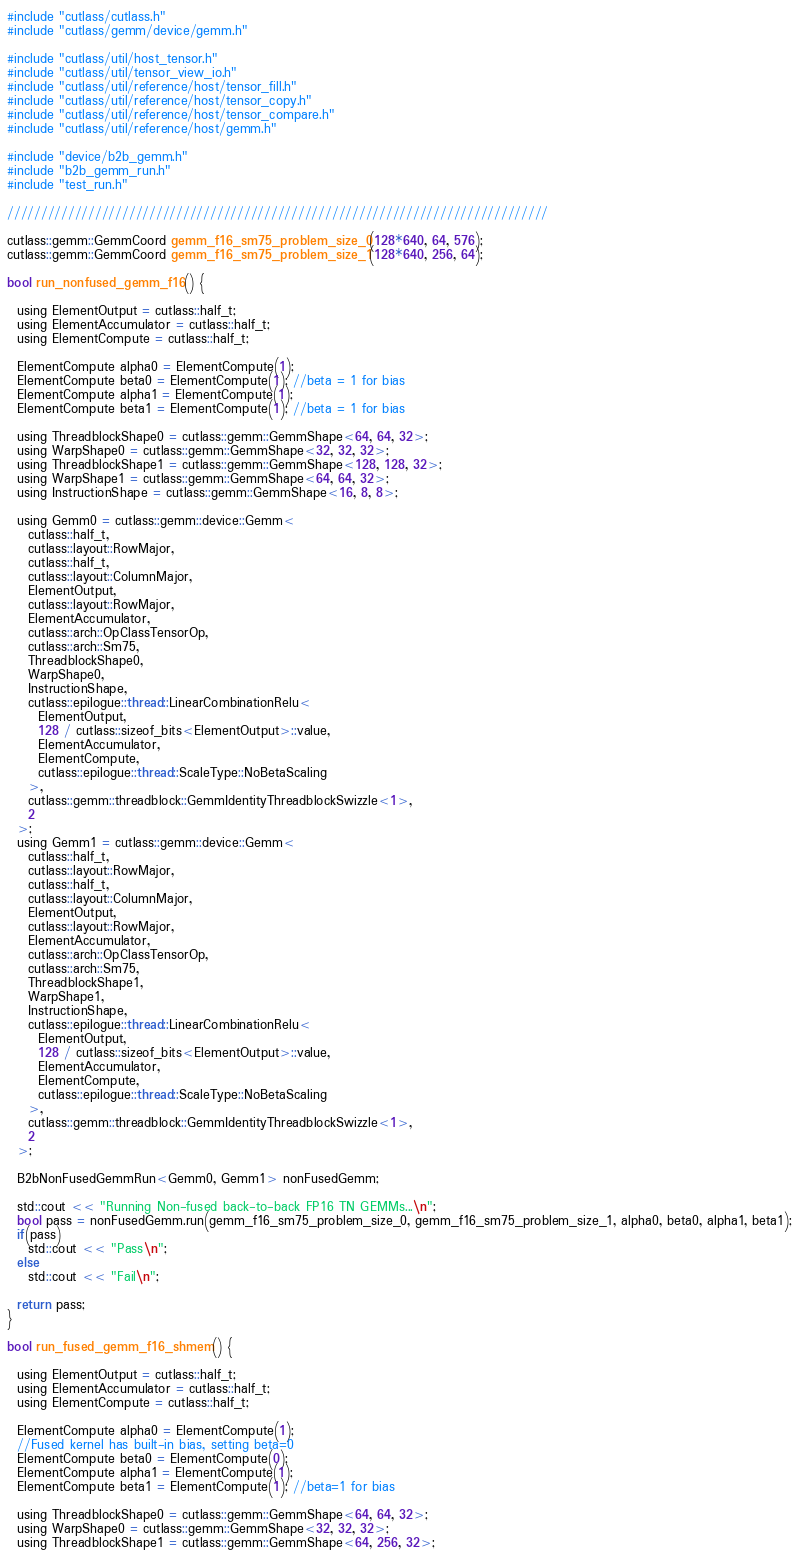Convert code to text. <code><loc_0><loc_0><loc_500><loc_500><_Cuda_>#include "cutlass/cutlass.h"
#include "cutlass/gemm/device/gemm.h"

#include "cutlass/util/host_tensor.h"
#include "cutlass/util/tensor_view_io.h"
#include "cutlass/util/reference/host/tensor_fill.h"
#include "cutlass/util/reference/host/tensor_copy.h"
#include "cutlass/util/reference/host/tensor_compare.h"
#include "cutlass/util/reference/host/gemm.h"

#include "device/b2b_gemm.h"
#include "b2b_gemm_run.h"
#include "test_run.h"

////////////////////////////////////////////////////////////////////////////////

cutlass::gemm::GemmCoord gemm_f16_sm75_problem_size_0(128*640, 64, 576);
cutlass::gemm::GemmCoord gemm_f16_sm75_problem_size_1(128*640, 256, 64);

bool run_nonfused_gemm_f16() {

  using ElementOutput = cutlass::half_t;
  using ElementAccumulator = cutlass::half_t;
  using ElementCompute = cutlass::half_t;

  ElementCompute alpha0 = ElementCompute(1);
  ElementCompute beta0 = ElementCompute(1); //beta = 1 for bias
  ElementCompute alpha1 = ElementCompute(1);
  ElementCompute beta1 = ElementCompute(1); //beta = 1 for bias

  using ThreadblockShape0 = cutlass::gemm::GemmShape<64, 64, 32>;
  using WarpShape0 = cutlass::gemm::GemmShape<32, 32, 32>;
  using ThreadblockShape1 = cutlass::gemm::GemmShape<128, 128, 32>;
  using WarpShape1 = cutlass::gemm::GemmShape<64, 64, 32>;
  using InstructionShape = cutlass::gemm::GemmShape<16, 8, 8>;

  using Gemm0 = cutlass::gemm::device::Gemm<
    cutlass::half_t,
    cutlass::layout::RowMajor,
    cutlass::half_t,
    cutlass::layout::ColumnMajor,
    ElementOutput,
    cutlass::layout::RowMajor,
    ElementAccumulator,
    cutlass::arch::OpClassTensorOp,
    cutlass::arch::Sm75,
    ThreadblockShape0,
    WarpShape0,
    InstructionShape,
    cutlass::epilogue::thread::LinearCombinationRelu<
      ElementOutput,
      128 / cutlass::sizeof_bits<ElementOutput>::value,
      ElementAccumulator,
      ElementCompute,
      cutlass::epilogue::thread::ScaleType::NoBetaScaling
    >,
    cutlass::gemm::threadblock::GemmIdentityThreadblockSwizzle<1>,
    2
  >;
  using Gemm1 = cutlass::gemm::device::Gemm<
    cutlass::half_t,
    cutlass::layout::RowMajor,
    cutlass::half_t,
    cutlass::layout::ColumnMajor,
    ElementOutput,
    cutlass::layout::RowMajor,
    ElementAccumulator,
    cutlass::arch::OpClassTensorOp,
    cutlass::arch::Sm75,
    ThreadblockShape1,
    WarpShape1,
    InstructionShape,
    cutlass::epilogue::thread::LinearCombinationRelu<
      ElementOutput,
      128 / cutlass::sizeof_bits<ElementOutput>::value,
      ElementAccumulator,
      ElementCompute,
      cutlass::epilogue::thread::ScaleType::NoBetaScaling
    >,
    cutlass::gemm::threadblock::GemmIdentityThreadblockSwizzle<1>,
    2
  >;

  B2bNonFusedGemmRun<Gemm0, Gemm1> nonFusedGemm;

  std::cout << "Running Non-fused back-to-back FP16 TN GEMMs...\n";
  bool pass = nonFusedGemm.run(gemm_f16_sm75_problem_size_0, gemm_f16_sm75_problem_size_1, alpha0, beta0, alpha1, beta1);
  if(pass)
    std::cout << "Pass\n";
  else
    std::cout << "Fail\n";

  return pass;
}

bool run_fused_gemm_f16_shmem() {

  using ElementOutput = cutlass::half_t;
  using ElementAccumulator = cutlass::half_t;
  using ElementCompute = cutlass::half_t;

  ElementCompute alpha0 = ElementCompute(1);
  //Fused kernel has built-in bias, setting beta=0
  ElementCompute beta0 = ElementCompute(0);
  ElementCompute alpha1 = ElementCompute(1);
  ElementCompute beta1 = ElementCompute(1); //beta=1 for bias

  using ThreadblockShape0 = cutlass::gemm::GemmShape<64, 64, 32>;
  using WarpShape0 = cutlass::gemm::GemmShape<32, 32, 32>;
  using ThreadblockShape1 = cutlass::gemm::GemmShape<64, 256, 32>;</code> 